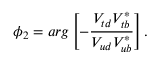<formula> <loc_0><loc_0><loc_500><loc_500>\phi _ { 2 } = \arg \left [ - \frac { V _ { t d } V _ { t b } ^ { * } } { V _ { u d } V _ { u b } ^ { * } } \right ] .</formula> 